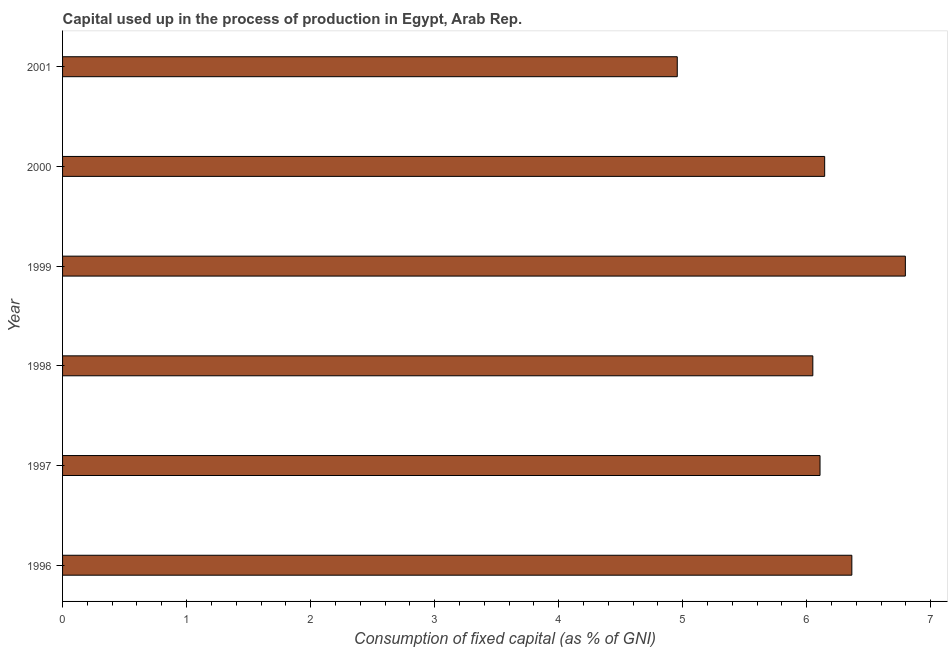What is the title of the graph?
Your answer should be very brief. Capital used up in the process of production in Egypt, Arab Rep. What is the label or title of the X-axis?
Provide a succinct answer. Consumption of fixed capital (as % of GNI). What is the consumption of fixed capital in 1996?
Provide a short and direct response. 6.36. Across all years, what is the maximum consumption of fixed capital?
Keep it short and to the point. 6.79. Across all years, what is the minimum consumption of fixed capital?
Provide a short and direct response. 4.96. In which year was the consumption of fixed capital minimum?
Offer a very short reply. 2001. What is the sum of the consumption of fixed capital?
Your response must be concise. 36.41. What is the difference between the consumption of fixed capital in 1999 and 2000?
Give a very brief answer. 0.65. What is the average consumption of fixed capital per year?
Your answer should be compact. 6.07. What is the median consumption of fixed capital?
Offer a terse response. 6.13. What is the ratio of the consumption of fixed capital in 1998 to that in 2000?
Your answer should be very brief. 0.98. What is the difference between the highest and the second highest consumption of fixed capital?
Offer a very short reply. 0.43. Is the sum of the consumption of fixed capital in 1997 and 1998 greater than the maximum consumption of fixed capital across all years?
Offer a very short reply. Yes. What is the difference between the highest and the lowest consumption of fixed capital?
Keep it short and to the point. 1.84. In how many years, is the consumption of fixed capital greater than the average consumption of fixed capital taken over all years?
Offer a very short reply. 4. Are all the bars in the graph horizontal?
Ensure brevity in your answer.  Yes. How many years are there in the graph?
Your answer should be very brief. 6. What is the difference between two consecutive major ticks on the X-axis?
Ensure brevity in your answer.  1. Are the values on the major ticks of X-axis written in scientific E-notation?
Provide a succinct answer. No. What is the Consumption of fixed capital (as % of GNI) in 1996?
Offer a terse response. 6.36. What is the Consumption of fixed capital (as % of GNI) of 1997?
Offer a very short reply. 6.11. What is the Consumption of fixed capital (as % of GNI) of 1998?
Provide a succinct answer. 6.05. What is the Consumption of fixed capital (as % of GNI) in 1999?
Your answer should be compact. 6.79. What is the Consumption of fixed capital (as % of GNI) of 2000?
Your answer should be very brief. 6.14. What is the Consumption of fixed capital (as % of GNI) in 2001?
Your answer should be very brief. 4.96. What is the difference between the Consumption of fixed capital (as % of GNI) in 1996 and 1997?
Keep it short and to the point. 0.26. What is the difference between the Consumption of fixed capital (as % of GNI) in 1996 and 1998?
Offer a very short reply. 0.31. What is the difference between the Consumption of fixed capital (as % of GNI) in 1996 and 1999?
Ensure brevity in your answer.  -0.43. What is the difference between the Consumption of fixed capital (as % of GNI) in 1996 and 2000?
Provide a succinct answer. 0.22. What is the difference between the Consumption of fixed capital (as % of GNI) in 1996 and 2001?
Your answer should be compact. 1.41. What is the difference between the Consumption of fixed capital (as % of GNI) in 1997 and 1998?
Offer a terse response. 0.06. What is the difference between the Consumption of fixed capital (as % of GNI) in 1997 and 1999?
Keep it short and to the point. -0.69. What is the difference between the Consumption of fixed capital (as % of GNI) in 1997 and 2000?
Ensure brevity in your answer.  -0.04. What is the difference between the Consumption of fixed capital (as % of GNI) in 1997 and 2001?
Offer a very short reply. 1.15. What is the difference between the Consumption of fixed capital (as % of GNI) in 1998 and 1999?
Keep it short and to the point. -0.75. What is the difference between the Consumption of fixed capital (as % of GNI) in 1998 and 2000?
Your answer should be very brief. -0.1. What is the difference between the Consumption of fixed capital (as % of GNI) in 1998 and 2001?
Your answer should be very brief. 1.09. What is the difference between the Consumption of fixed capital (as % of GNI) in 1999 and 2000?
Give a very brief answer. 0.65. What is the difference between the Consumption of fixed capital (as % of GNI) in 1999 and 2001?
Make the answer very short. 1.84. What is the difference between the Consumption of fixed capital (as % of GNI) in 2000 and 2001?
Your answer should be compact. 1.19. What is the ratio of the Consumption of fixed capital (as % of GNI) in 1996 to that in 1997?
Your answer should be very brief. 1.04. What is the ratio of the Consumption of fixed capital (as % of GNI) in 1996 to that in 1998?
Your answer should be very brief. 1.05. What is the ratio of the Consumption of fixed capital (as % of GNI) in 1996 to that in 1999?
Your answer should be very brief. 0.94. What is the ratio of the Consumption of fixed capital (as % of GNI) in 1996 to that in 2000?
Your answer should be compact. 1.04. What is the ratio of the Consumption of fixed capital (as % of GNI) in 1996 to that in 2001?
Your answer should be compact. 1.28. What is the ratio of the Consumption of fixed capital (as % of GNI) in 1997 to that in 1998?
Provide a succinct answer. 1.01. What is the ratio of the Consumption of fixed capital (as % of GNI) in 1997 to that in 1999?
Your response must be concise. 0.9. What is the ratio of the Consumption of fixed capital (as % of GNI) in 1997 to that in 2000?
Your answer should be very brief. 0.99. What is the ratio of the Consumption of fixed capital (as % of GNI) in 1997 to that in 2001?
Your answer should be very brief. 1.23. What is the ratio of the Consumption of fixed capital (as % of GNI) in 1998 to that in 1999?
Make the answer very short. 0.89. What is the ratio of the Consumption of fixed capital (as % of GNI) in 1998 to that in 2000?
Your answer should be very brief. 0.98. What is the ratio of the Consumption of fixed capital (as % of GNI) in 1998 to that in 2001?
Your answer should be very brief. 1.22. What is the ratio of the Consumption of fixed capital (as % of GNI) in 1999 to that in 2000?
Offer a very short reply. 1.11. What is the ratio of the Consumption of fixed capital (as % of GNI) in 1999 to that in 2001?
Keep it short and to the point. 1.37. What is the ratio of the Consumption of fixed capital (as % of GNI) in 2000 to that in 2001?
Provide a succinct answer. 1.24. 